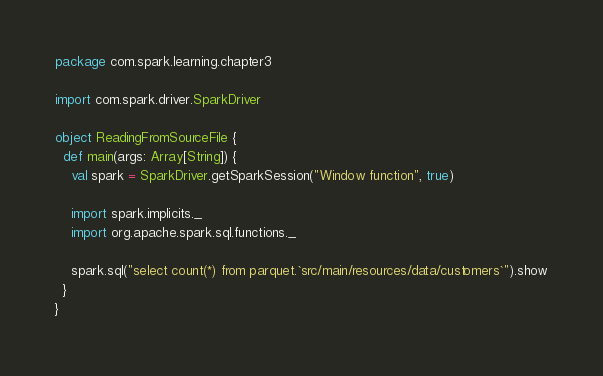<code> <loc_0><loc_0><loc_500><loc_500><_Scala_>package com.spark.learning.chapter3

import com.spark.driver.SparkDriver

object ReadingFromSourceFile {
  def main(args: Array[String]) {
    val spark = SparkDriver.getSparkSession("Window function", true)

    import spark.implicits._
    import org.apache.spark.sql.functions._

    spark.sql("select count(*) from parquet.`src/main/resources/data/customers`").show
  }
}</code> 